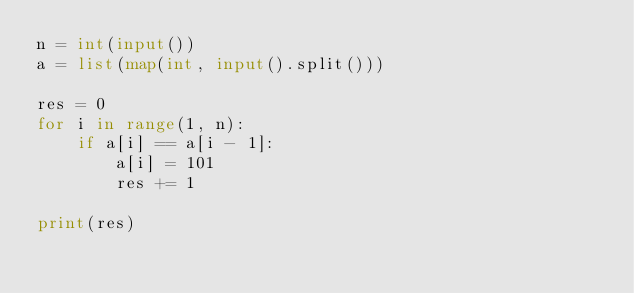Convert code to text. <code><loc_0><loc_0><loc_500><loc_500><_Python_>n = int(input())
a = list(map(int, input().split()))

res = 0
for i in range(1, n):
    if a[i] == a[i - 1]:
        a[i] = 101
        res += 1

print(res)</code> 